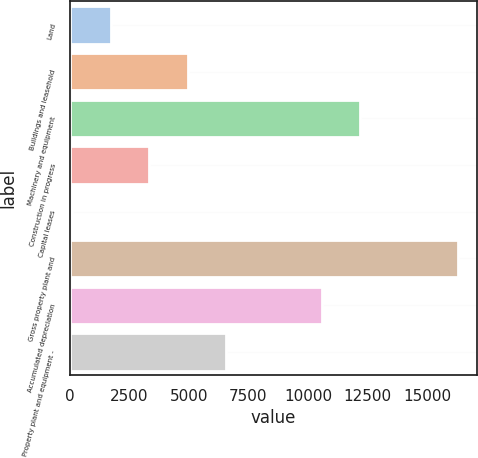<chart> <loc_0><loc_0><loc_500><loc_500><bar_chart><fcel>Land<fcel>Buildings and leasehold<fcel>Machinery and equipment<fcel>Construction in progress<fcel>Capital leases<fcel>Gross property plant and<fcel>Accumulated depreciation<fcel>Property plant and equipment -<nl><fcel>1719.9<fcel>4957.7<fcel>12197.9<fcel>3338.8<fcel>101<fcel>16290<fcel>10579<fcel>6576.6<nl></chart> 